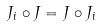Convert formula to latex. <formula><loc_0><loc_0><loc_500><loc_500>J _ { i } \circ J = J \circ J _ { i }</formula> 